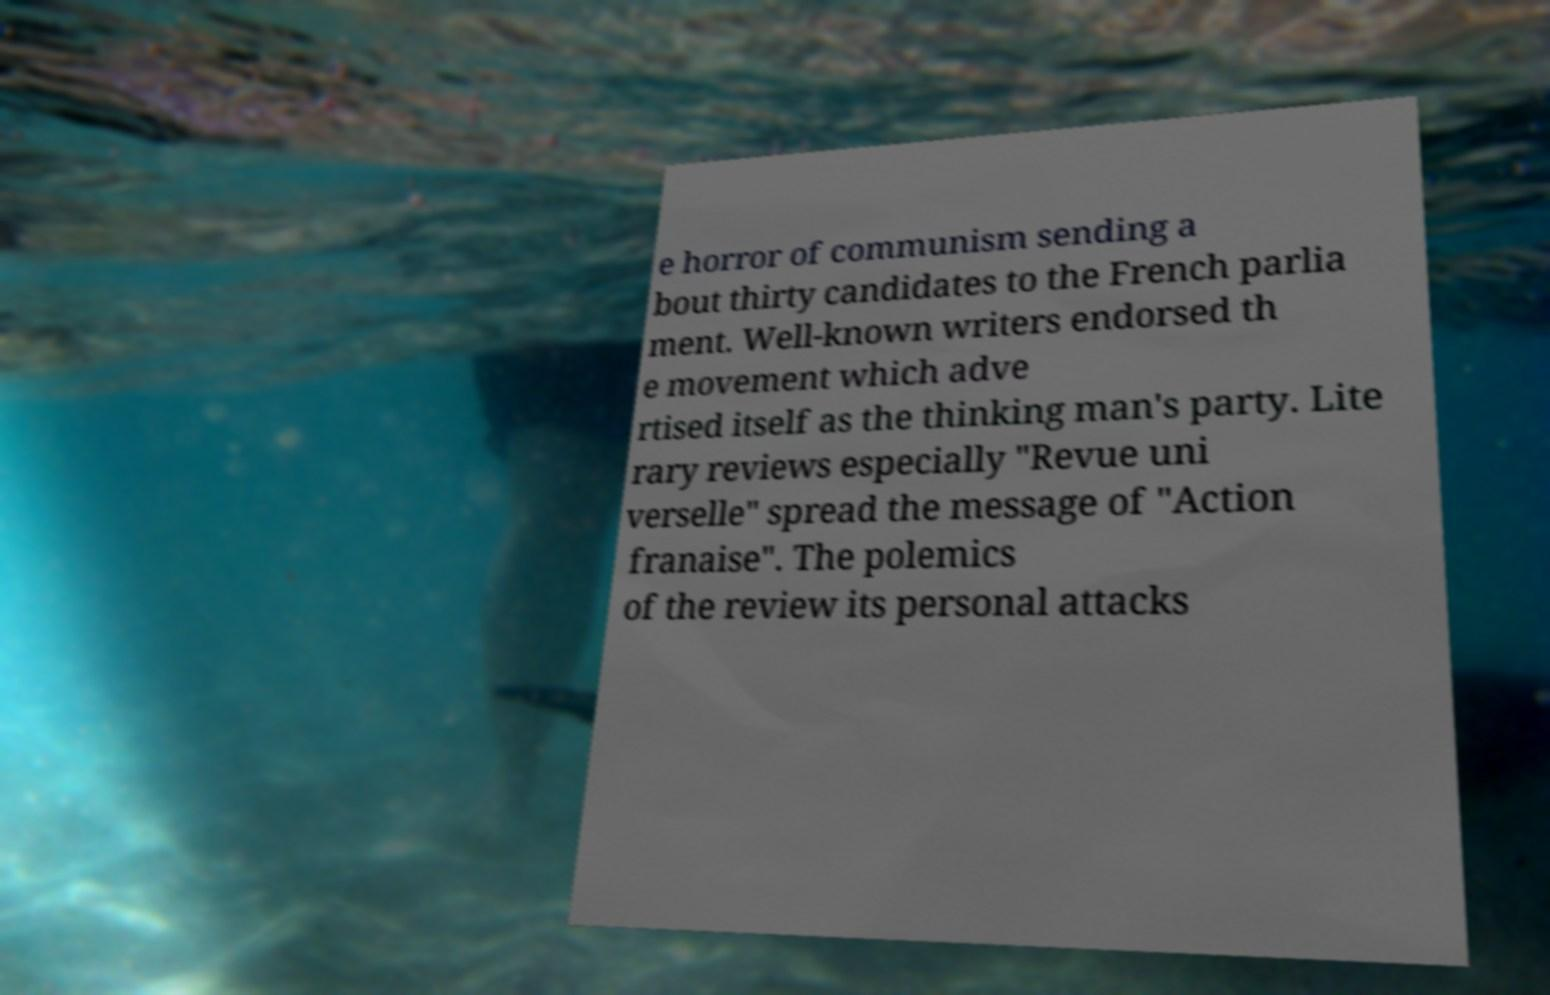Please identify and transcribe the text found in this image. e horror of communism sending a bout thirty candidates to the French parlia ment. Well-known writers endorsed th e movement which adve rtised itself as the thinking man's party. Lite rary reviews especially "Revue uni verselle" spread the message of "Action franaise". The polemics of the review its personal attacks 